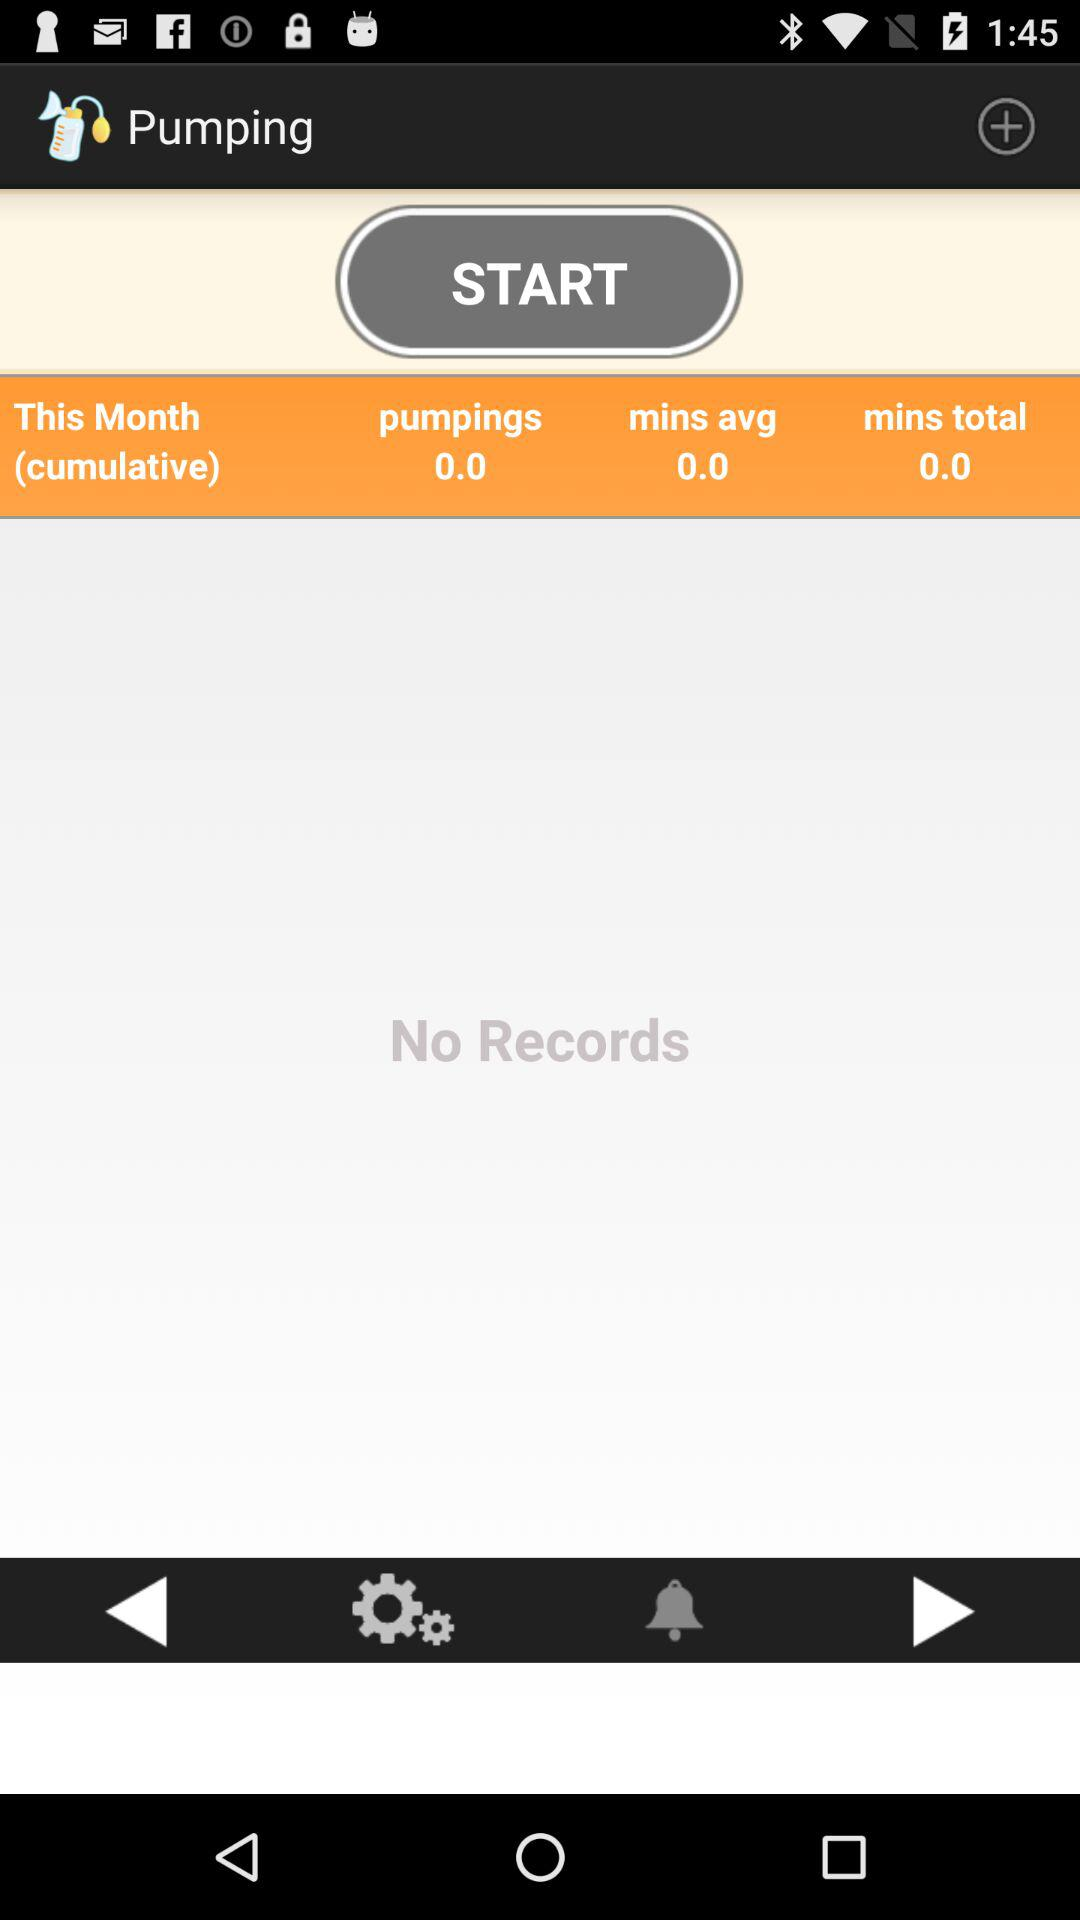Is there any record? There are no records. 